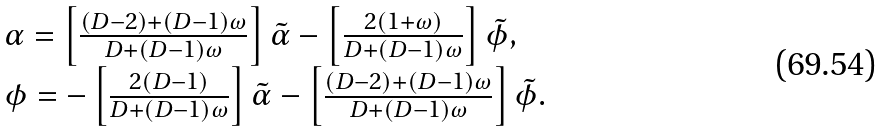<formula> <loc_0><loc_0><loc_500><loc_500>\begin{array} { l l l } { \alpha } = \left [ \frac { ( D - 2 ) + ( D - 1 ) \omega } { D + ( D - 1 ) \omega } \right ] \tilde { \alpha } - \left [ \frac { 2 ( 1 + \omega ) } { D + ( D - 1 ) \omega } \right ] \tilde { \phi } , \\ \phi = - \left [ \frac { 2 ( D - 1 ) } { D + ( D - 1 ) \omega } \right ] \tilde { \alpha } - \left [ \frac { ( D - 2 ) + ( D - 1 ) \omega } { D + ( D - 1 ) \omega } \right ] \tilde { \phi } . \end{array}</formula> 